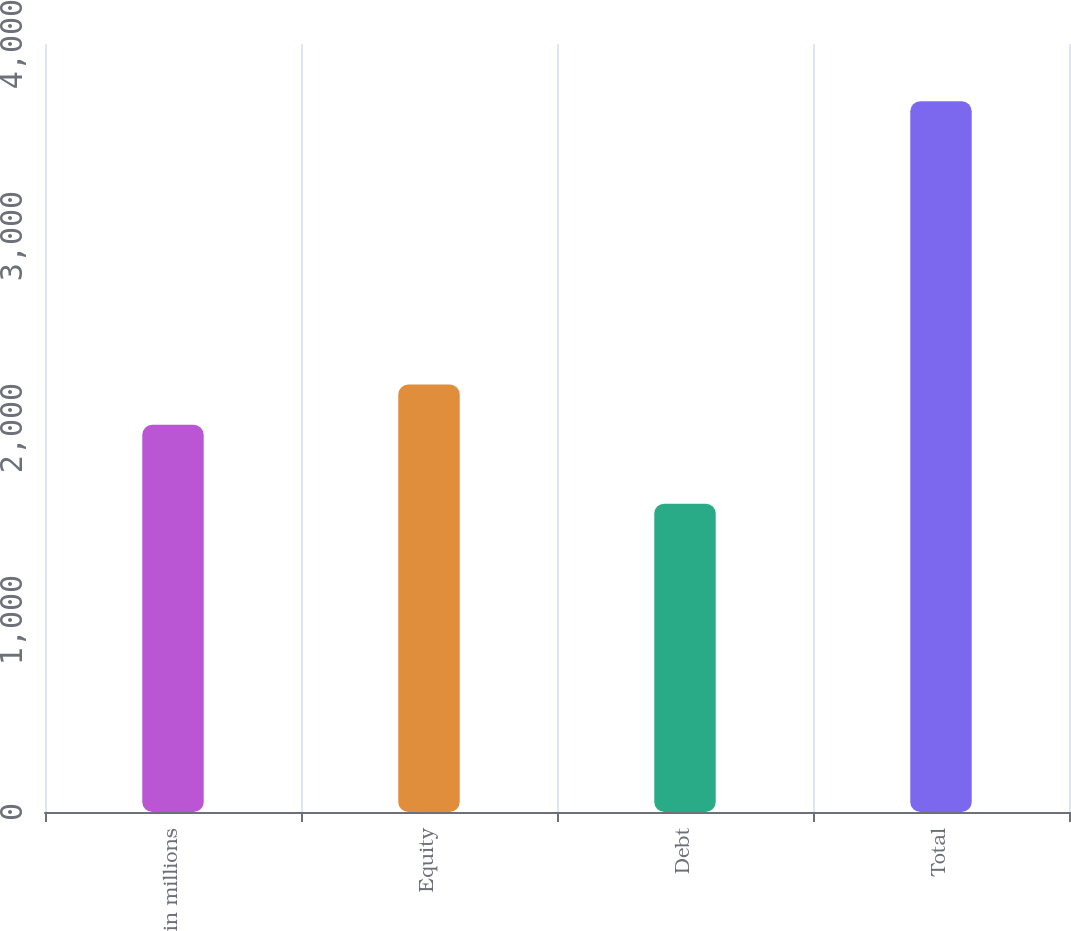Convert chart to OTSL. <chart><loc_0><loc_0><loc_500><loc_500><bar_chart><fcel>in millions<fcel>Equity<fcel>Debt<fcel>Total<nl><fcel>2017<fcel>2226.6<fcel>1606<fcel>3702<nl></chart> 